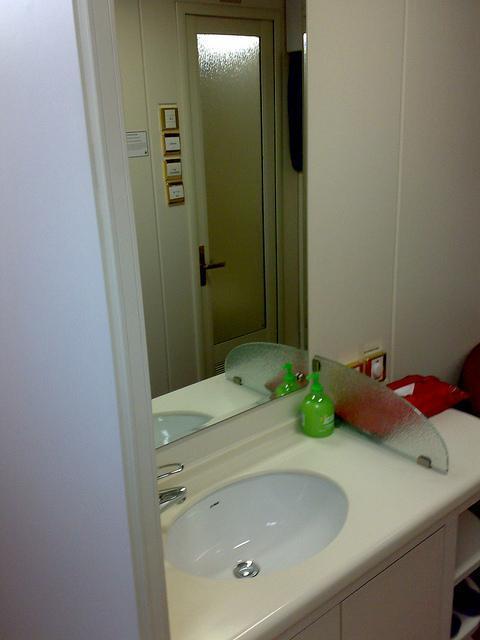How many people are wearing yellow?
Give a very brief answer. 0. 